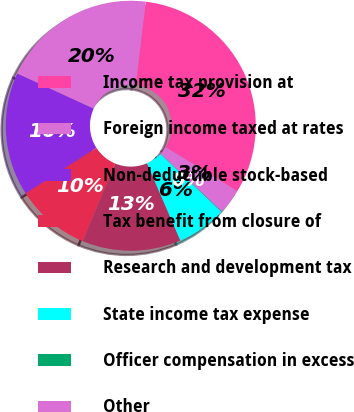Convert chart to OTSL. <chart><loc_0><loc_0><loc_500><loc_500><pie_chart><fcel>Income tax provision at<fcel>Foreign income taxed at rates<fcel>Non-deductible stock-based<fcel>Tax benefit from closure of<fcel>Research and development tax<fcel>State income tax expense<fcel>Officer compensation in excess<fcel>Other<nl><fcel>31.85%<fcel>20.05%<fcel>15.96%<fcel>9.61%<fcel>12.78%<fcel>6.43%<fcel>0.07%<fcel>3.25%<nl></chart> 